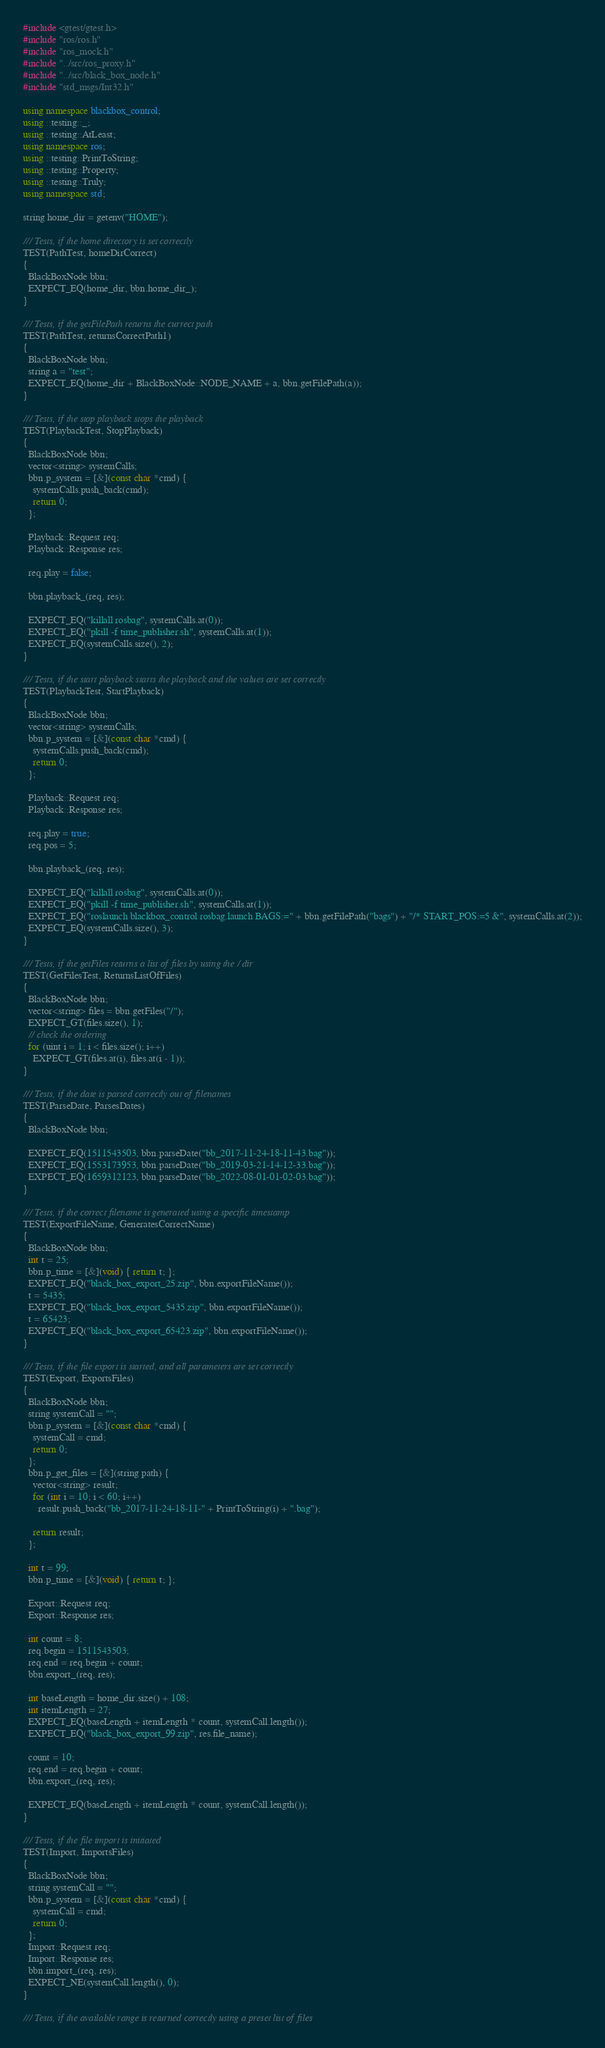<code> <loc_0><loc_0><loc_500><loc_500><_C++_>#include <gtest/gtest.h>
#include "ros/ros.h"
#include "ros_mock.h"
#include "../src/ros_proxy.h"
#include "../src/black_box_node.h"
#include "std_msgs/Int32.h"

using namespace blackbox_control;
using ::testing::_;
using ::testing::AtLeast;
using namespace ros;
using ::testing::PrintToString;
using ::testing::Property;
using ::testing::Truly;
using namespace std;

string home_dir = getenv("HOME");

/// Tests, if the home directory is set correctly
TEST(PathTest, homeDirCorrect)
{
  BlackBoxNode bbn;
  EXPECT_EQ(home_dir, bbn.home_dir_);
}

/// Tests, if the getFilePath returns the currect path
TEST(PathTest, returnsCorrectPath1)
{
  BlackBoxNode bbn;
  string a = "test";
  EXPECT_EQ(home_dir + BlackBoxNode::NODE_NAME + a, bbn.getFilePath(a));
}

/// Tests, if the stop playback stops the playback
TEST(PlaybackTest, StopPlayback)
{
  BlackBoxNode bbn;
  vector<string> systemCalls;
  bbn.p_system = [&](const char *cmd) {
    systemCalls.push_back(cmd);
    return 0;
  };

  Playback::Request req;
  Playback::Response res;

  req.play = false;

  bbn.playback_(req, res);

  EXPECT_EQ("killall rosbag", systemCalls.at(0));
  EXPECT_EQ("pkill -f time_publisher.sh", systemCalls.at(1));
  EXPECT_EQ(systemCalls.size(), 2);
}

/// Tests, if the start playback starts the playback and the values are set correctly
TEST(PlaybackTest, StartPlayback)
{
  BlackBoxNode bbn;
  vector<string> systemCalls;
  bbn.p_system = [&](const char *cmd) {
    systemCalls.push_back(cmd);
    return 0;
  };

  Playback::Request req;
  Playback::Response res;

  req.play = true;
  req.pos = 5;

  bbn.playback_(req, res);

  EXPECT_EQ("killall rosbag", systemCalls.at(0));
  EXPECT_EQ("pkill -f time_publisher.sh", systemCalls.at(1));
  EXPECT_EQ("roslaunch blackbox_control rosbag.launch BAGS:=" + bbn.getFilePath("bags") + "/* START_POS:=5 &", systemCalls.at(2));
  EXPECT_EQ(systemCalls.size(), 3);
}

/// Tests, if the getFiles returns a list of files by using the / dir
TEST(GetFilesTest, ReturnsListOfFiles)
{
  BlackBoxNode bbn;
  vector<string> files = bbn.getFiles("/");
  EXPECT_GT(files.size(), 1);
  // check the ordering
  for (uint i = 1; i < files.size(); i++)
    EXPECT_GT(files.at(i), files.at(i - 1));
}

/// Tests, if the date is parsed correctly out of filenames
TEST(ParseDate, ParsesDates)
{
  BlackBoxNode bbn;

  EXPECT_EQ(1511543503, bbn.parseDate("bb_2017-11-24-18-11-43.bag"));
  EXPECT_EQ(1553173953, bbn.parseDate("bb_2019-03-21-14-12-33.bag"));
  EXPECT_EQ(1659312123, bbn.parseDate("bb_2022-08-01-01-02-03.bag"));
}

/// Tests, if the correct filename is generated using a specific timestamp
TEST(ExportFileName, GeneratesCorrectName)
{
  BlackBoxNode bbn;
  int t = 25;
  bbn.p_time = [&](void) { return t; };
  EXPECT_EQ("black_box_export_25.zip", bbn.exportFileName());
  t = 5435;
  EXPECT_EQ("black_box_export_5435.zip", bbn.exportFileName());
  t = 65423;
  EXPECT_EQ("black_box_export_65423.zip", bbn.exportFileName());
}

/// Tests, if the file export is started, and all parameters are set correctly
TEST(Export, ExportsFiles)
{
  BlackBoxNode bbn;
  string systemCall = "";
  bbn.p_system = [&](const char *cmd) {
    systemCall = cmd;
    return 0;
  };
  bbn.p_get_files = [&](string path) {
    vector<string> result;
    for (int i = 10; i < 60; i++)
      result.push_back("bb_2017-11-24-18-11-" + PrintToString(i) + ".bag");

    return result;
  };

  int t = 99;
  bbn.p_time = [&](void) { return t; };

  Export::Request req;
  Export::Response res;

  int count = 8;
  req.begin = 1511543503;
  req.end = req.begin + count;
  bbn.export_(req, res);

  int baseLength = home_dir.size() + 108;
  int itemLength = 27;
  EXPECT_EQ(baseLength + itemLength * count, systemCall.length());
  EXPECT_EQ("black_box_export_99.zip", res.file_name);

  count = 10;
  req.end = req.begin + count;
  bbn.export_(req, res);

  EXPECT_EQ(baseLength + itemLength * count, systemCall.length());
}

/// Tests, if the file import is initiated
TEST(Import, ImportsFiles)
{
  BlackBoxNode bbn;
  string systemCall = "";
  bbn.p_system = [&](const char *cmd) {
    systemCall = cmd;
    return 0;
  };
  Import::Request req;
  Import::Response res;
  bbn.import_(req, res);
  EXPECT_NE(systemCall.length(), 0);
}

/// Tests, if the available range is returned correctly using a preset list of files</code> 